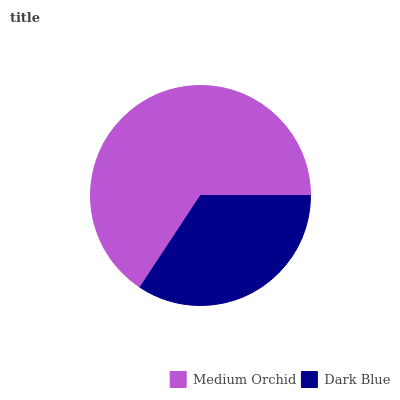Is Dark Blue the minimum?
Answer yes or no. Yes. Is Medium Orchid the maximum?
Answer yes or no. Yes. Is Dark Blue the maximum?
Answer yes or no. No. Is Medium Orchid greater than Dark Blue?
Answer yes or no. Yes. Is Dark Blue less than Medium Orchid?
Answer yes or no. Yes. Is Dark Blue greater than Medium Orchid?
Answer yes or no. No. Is Medium Orchid less than Dark Blue?
Answer yes or no. No. Is Medium Orchid the high median?
Answer yes or no. Yes. Is Dark Blue the low median?
Answer yes or no. Yes. Is Dark Blue the high median?
Answer yes or no. No. Is Medium Orchid the low median?
Answer yes or no. No. 